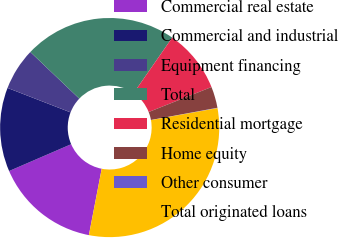Convert chart. <chart><loc_0><loc_0><loc_500><loc_500><pie_chart><fcel>Commercial real estate<fcel>Commercial and industrial<fcel>Equipment financing<fcel>Total<fcel>Residential mortgage<fcel>Home equity<fcel>Other consumer<fcel>Total originated loans<nl><fcel>15.47%<fcel>12.38%<fcel>6.22%<fcel>22.56%<fcel>9.3%<fcel>3.14%<fcel>0.05%<fcel>30.88%<nl></chart> 